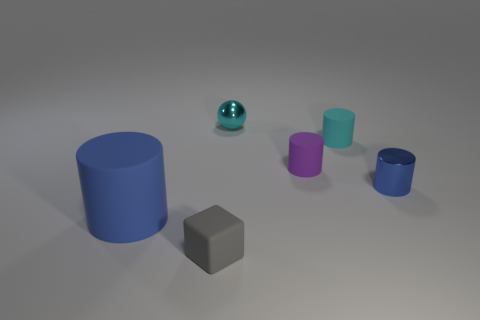Subtract 1 cylinders. How many cylinders are left? 3 Add 2 blue cylinders. How many objects exist? 8 Subtract all cylinders. How many objects are left? 2 Subtract 0 gray cylinders. How many objects are left? 6 Subtract all large things. Subtract all small metallic objects. How many objects are left? 3 Add 1 big rubber cylinders. How many big rubber cylinders are left? 2 Add 1 cyan blocks. How many cyan blocks exist? 1 